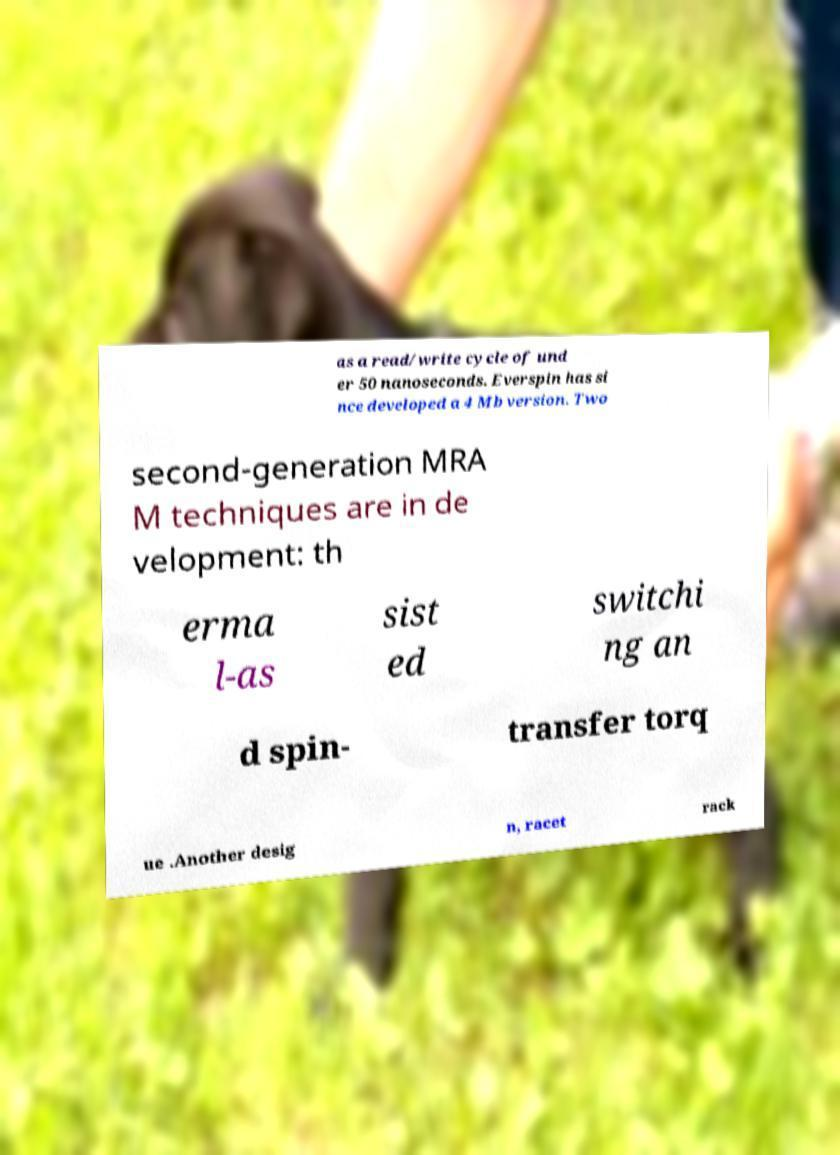Can you read and provide the text displayed in the image?This photo seems to have some interesting text. Can you extract and type it out for me? as a read/write cycle of und er 50 nanoseconds. Everspin has si nce developed a 4 Mb version. Two second-generation MRA M techniques are in de velopment: th erma l-as sist ed switchi ng an d spin- transfer torq ue .Another desig n, racet rack 